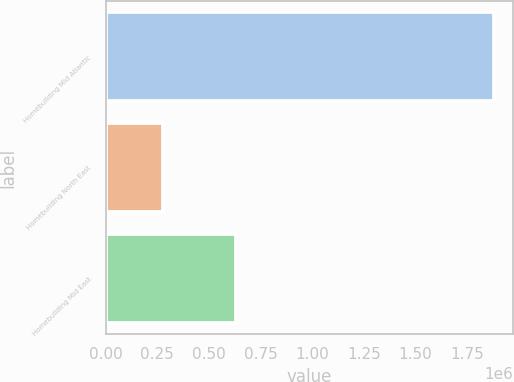Convert chart. <chart><loc_0><loc_0><loc_500><loc_500><bar_chart><fcel>Homebuilding Mid Atlantic<fcel>Homebuilding North East<fcel>Homebuilding Mid East<nl><fcel>1.8779e+06<fcel>278715<fcel>630367<nl></chart> 